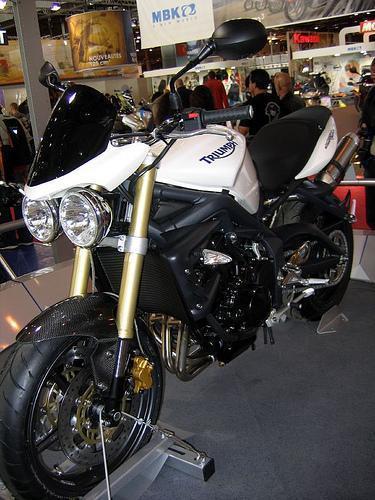What kind of bike is this?
Make your selection and explain in format: 'Answer: answer
Rationale: rationale.'
Options: Scooter, motorbike, bicycle, vespa. Answer: motorbike.
Rationale: The other options wouldn't apply in this image. 